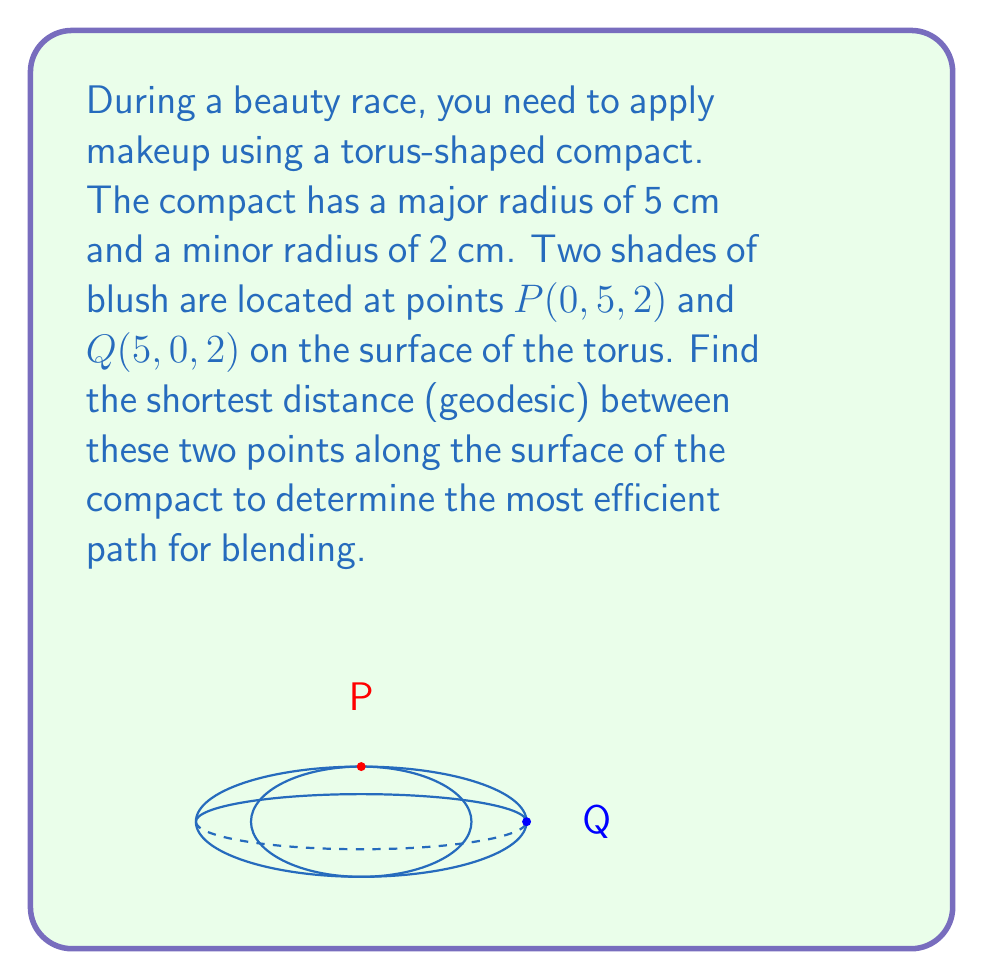Can you answer this question? To find the geodesic distance between two points on a torus, we need to follow these steps:

1) First, we need to parameterize the torus. A standard parameterization is:
   $x = (R + r\cos\phi)\cos\theta$
   $y = (R + r\cos\phi)\sin\theta$
   $z = r\sin\phi$
   where $R$ is the major radius, $r$ is the minor radius, $0 \leq \theta < 2\pi$, and $0 \leq \phi < 2\pi$.

2) From the given coordinates, we can determine that:
   $P: \theta_1 = 0, \phi_1 = \pi/2$
   $Q: \theta_2 = \pi/2, \phi_2 = \pi/2$

3) The geodesic distance on a torus can be approximated by the formula:
   $$d \approx \sqrt{R^2(\theta_2 - \theta_1)^2 + r^2(\phi_2 - \phi_1)^2}$$

4) Substituting our values:
   $$d \approx \sqrt{5^2(\pi/2 - 0)^2 + 2^2(\pi/2 - \pi/2)^2}$$

5) Simplifying:
   $$d \approx \sqrt{25(\pi/2)^2 + 0^2} = 5\pi/2 \approx 7.85 \text{ cm}$$

This approximation is quite accurate for a torus with a large ratio of R to r, as in this case.
Answer: $5\pi/2 \approx 7.85 \text{ cm}$ 